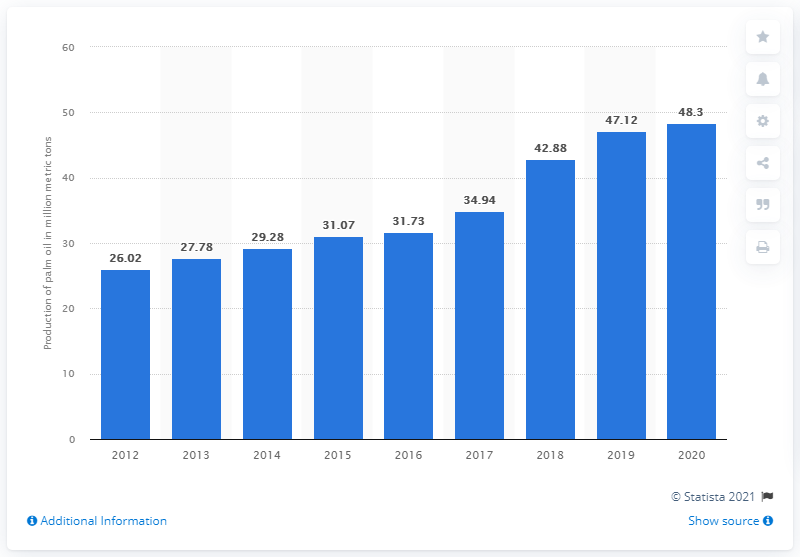Outline some significant characteristics in this image. In 2020, Indonesia produced 48.3 million metric tons of palm oil. 